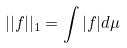<formula> <loc_0><loc_0><loc_500><loc_500>| | f | | _ { 1 } = \int | f | d \mu</formula> 